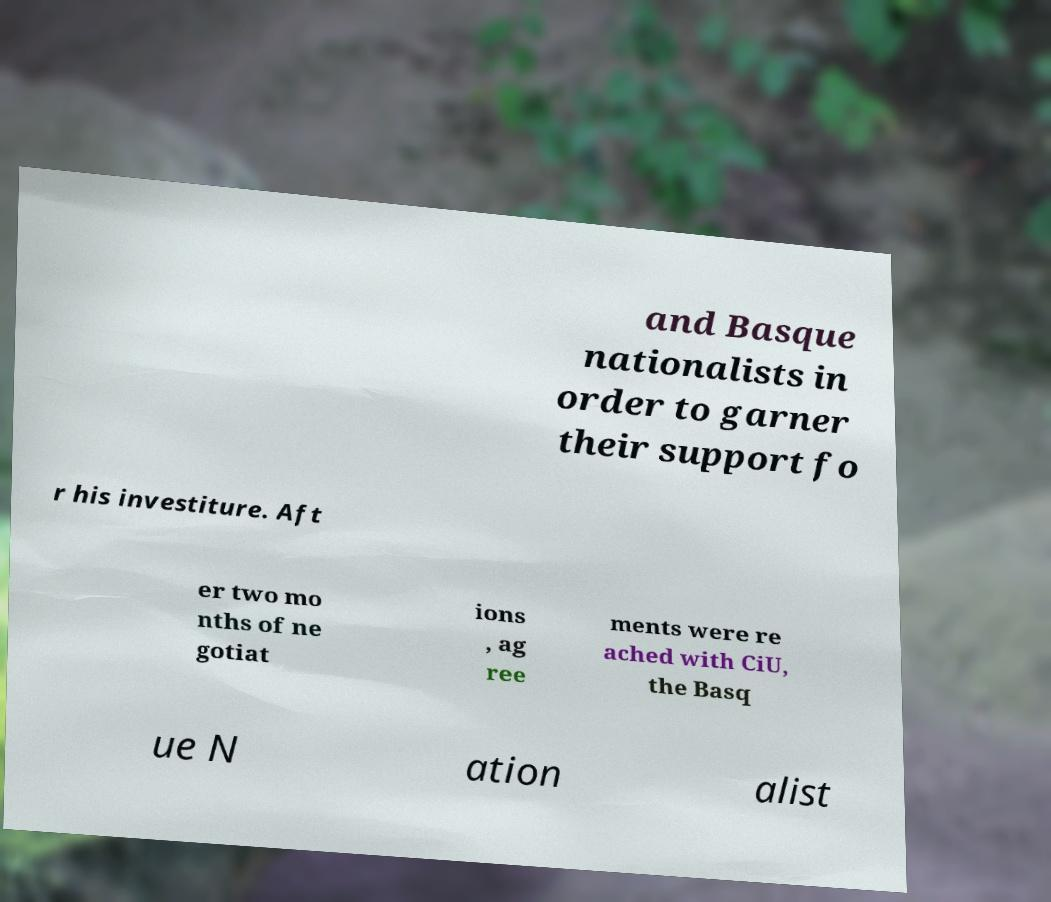Could you assist in decoding the text presented in this image and type it out clearly? and Basque nationalists in order to garner their support fo r his investiture. Aft er two mo nths of ne gotiat ions , ag ree ments were re ached with CiU, the Basq ue N ation alist 